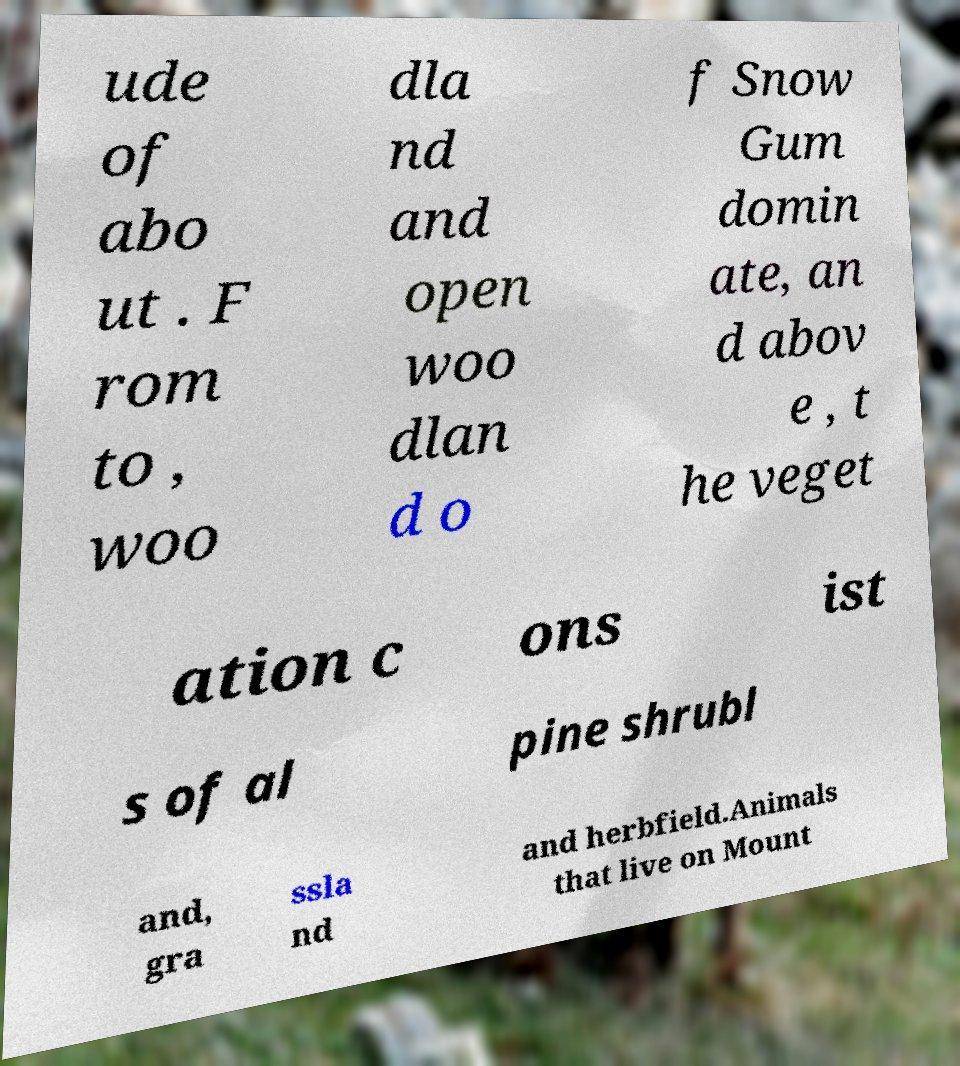I need the written content from this picture converted into text. Can you do that? ude of abo ut . F rom to , woo dla nd and open woo dlan d o f Snow Gum domin ate, an d abov e , t he veget ation c ons ist s of al pine shrubl and, gra ssla nd and herbfield.Animals that live on Mount 